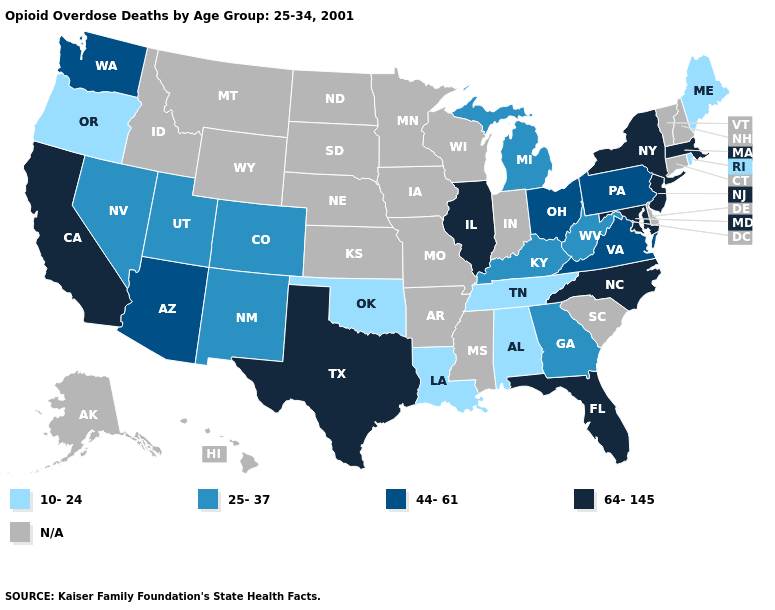Which states have the lowest value in the USA?
Answer briefly. Alabama, Louisiana, Maine, Oklahoma, Oregon, Rhode Island, Tennessee. Does North Carolina have the lowest value in the USA?
Answer briefly. No. What is the lowest value in the South?
Short answer required. 10-24. What is the lowest value in the USA?
Write a very short answer. 10-24. What is the lowest value in the MidWest?
Write a very short answer. 25-37. Which states hav the highest value in the Northeast?
Short answer required. Massachusetts, New Jersey, New York. Name the states that have a value in the range 10-24?
Write a very short answer. Alabama, Louisiana, Maine, Oklahoma, Oregon, Rhode Island, Tennessee. What is the value of Indiana?
Write a very short answer. N/A. Among the states that border Mississippi , which have the highest value?
Concise answer only. Alabama, Louisiana, Tennessee. Does the first symbol in the legend represent the smallest category?
Keep it brief. Yes. What is the lowest value in the USA?
Keep it brief. 10-24. Does New York have the lowest value in the Northeast?
Quick response, please. No. Name the states that have a value in the range 64-145?
Quick response, please. California, Florida, Illinois, Maryland, Massachusetts, New Jersey, New York, North Carolina, Texas. 